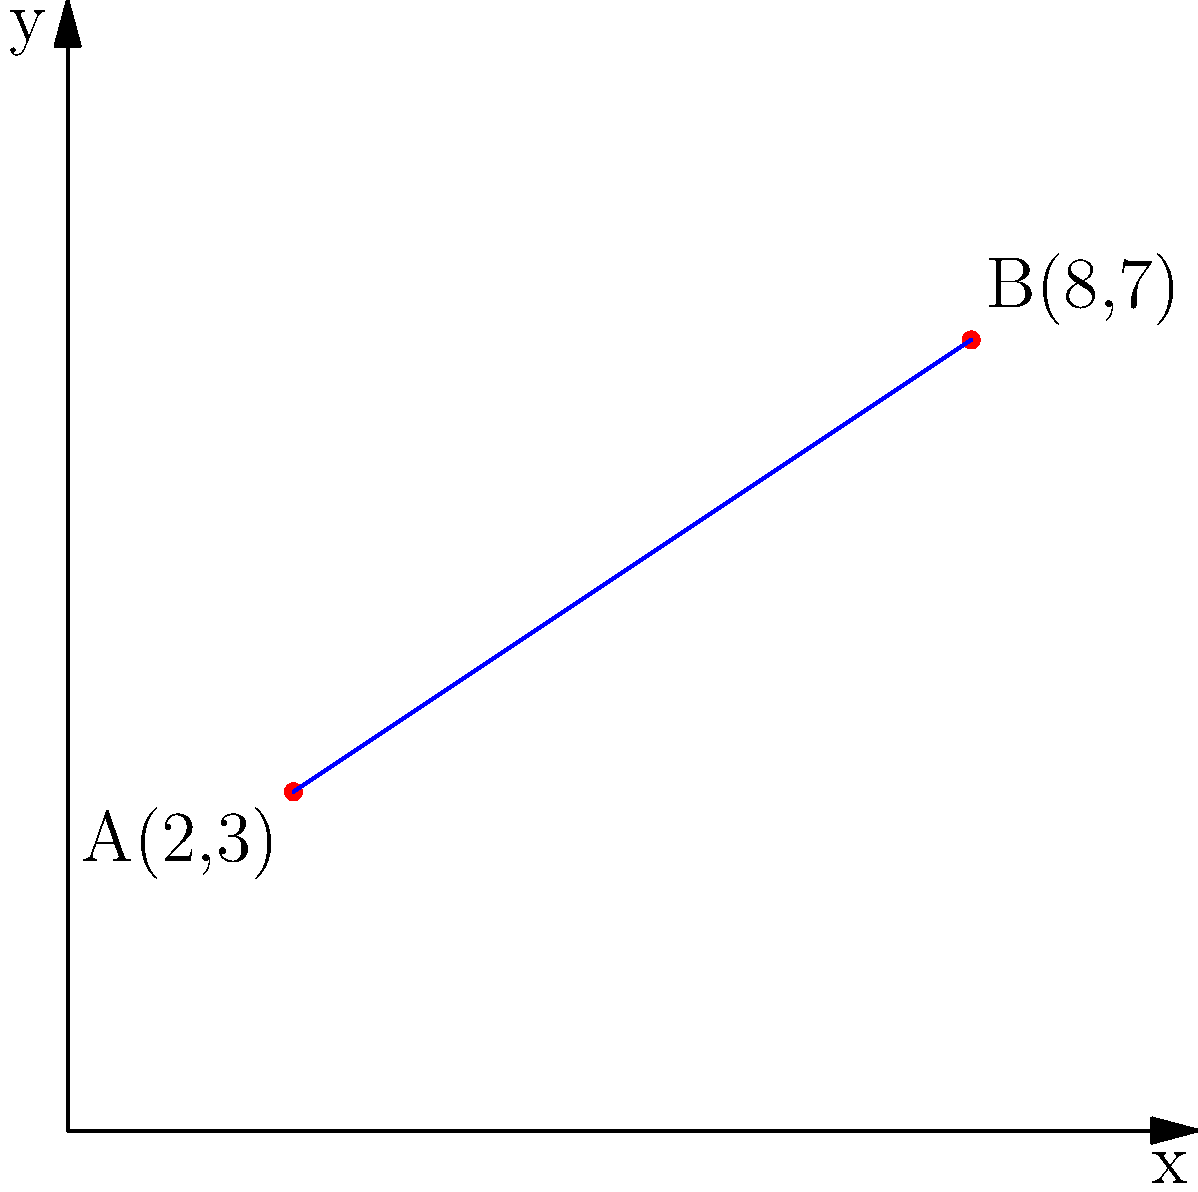During your daughter's journey, you've tracked her location at two points: A(2,3) and B(8,7). Calculate the slope of the line connecting these two points to understand the trajectory of her journey. What is the slope of line AB? To find the slope of a line connecting two points, we use the slope formula:

$$ m = \frac{y_2 - y_1}{x_2 - x_1} $$

Where $(x_1, y_1)$ is the first point and $(x_2, y_2)$ is the second point.

Given:
Point A: $(x_1, y_1) = (2, 3)$
Point B: $(x_2, y_2) = (8, 7)$

Let's substitute these values into the formula:

$$ m = \frac{7 - 3}{8 - 2} = \frac{4}{6} $$

Simplify the fraction:

$$ m = \frac{4}{6} = \frac{2}{3} $$

Therefore, the slope of line AB is $\frac{2}{3}$.
Answer: $\frac{2}{3}$ 